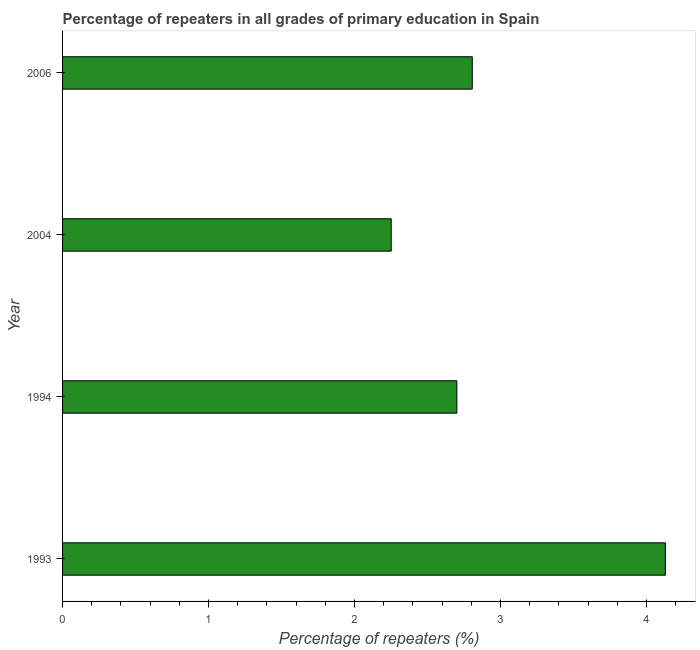Does the graph contain grids?
Keep it short and to the point. No. What is the title of the graph?
Your response must be concise. Percentage of repeaters in all grades of primary education in Spain. What is the label or title of the X-axis?
Make the answer very short. Percentage of repeaters (%). What is the percentage of repeaters in primary education in 1994?
Your answer should be compact. 2.7. Across all years, what is the maximum percentage of repeaters in primary education?
Provide a succinct answer. 4.13. Across all years, what is the minimum percentage of repeaters in primary education?
Give a very brief answer. 2.25. In which year was the percentage of repeaters in primary education maximum?
Your response must be concise. 1993. In which year was the percentage of repeaters in primary education minimum?
Provide a succinct answer. 2004. What is the sum of the percentage of repeaters in primary education?
Your answer should be very brief. 11.89. What is the difference between the percentage of repeaters in primary education in 2004 and 2006?
Offer a very short reply. -0.56. What is the average percentage of repeaters in primary education per year?
Keep it short and to the point. 2.97. What is the median percentage of repeaters in primary education?
Offer a very short reply. 2.75. In how many years, is the percentage of repeaters in primary education greater than 2.8 %?
Make the answer very short. 2. Do a majority of the years between 2006 and 2004 (inclusive) have percentage of repeaters in primary education greater than 3 %?
Your answer should be very brief. No. What is the ratio of the percentage of repeaters in primary education in 1993 to that in 2006?
Offer a very short reply. 1.47. Is the percentage of repeaters in primary education in 1993 less than that in 1994?
Your response must be concise. No. Is the difference between the percentage of repeaters in primary education in 2004 and 2006 greater than the difference between any two years?
Give a very brief answer. No. What is the difference between the highest and the second highest percentage of repeaters in primary education?
Provide a short and direct response. 1.32. Is the sum of the percentage of repeaters in primary education in 2004 and 2006 greater than the maximum percentage of repeaters in primary education across all years?
Offer a very short reply. Yes. What is the difference between the highest and the lowest percentage of repeaters in primary education?
Ensure brevity in your answer.  1.88. How many years are there in the graph?
Make the answer very short. 4. What is the difference between two consecutive major ticks on the X-axis?
Keep it short and to the point. 1. Are the values on the major ticks of X-axis written in scientific E-notation?
Provide a succinct answer. No. What is the Percentage of repeaters (%) of 1993?
Ensure brevity in your answer.  4.13. What is the Percentage of repeaters (%) of 1994?
Your answer should be very brief. 2.7. What is the Percentage of repeaters (%) of 2004?
Your answer should be very brief. 2.25. What is the Percentage of repeaters (%) of 2006?
Provide a short and direct response. 2.81. What is the difference between the Percentage of repeaters (%) in 1993 and 1994?
Offer a very short reply. 1.43. What is the difference between the Percentage of repeaters (%) in 1993 and 2004?
Make the answer very short. 1.88. What is the difference between the Percentage of repeaters (%) in 1993 and 2006?
Your answer should be compact. 1.32. What is the difference between the Percentage of repeaters (%) in 1994 and 2004?
Keep it short and to the point. 0.45. What is the difference between the Percentage of repeaters (%) in 1994 and 2006?
Your answer should be very brief. -0.11. What is the difference between the Percentage of repeaters (%) in 2004 and 2006?
Provide a short and direct response. -0.56. What is the ratio of the Percentage of repeaters (%) in 1993 to that in 1994?
Give a very brief answer. 1.53. What is the ratio of the Percentage of repeaters (%) in 1993 to that in 2004?
Ensure brevity in your answer.  1.83. What is the ratio of the Percentage of repeaters (%) in 1993 to that in 2006?
Give a very brief answer. 1.47. What is the ratio of the Percentage of repeaters (%) in 1994 to that in 2004?
Your answer should be very brief. 1.2. What is the ratio of the Percentage of repeaters (%) in 1994 to that in 2006?
Provide a succinct answer. 0.96. What is the ratio of the Percentage of repeaters (%) in 2004 to that in 2006?
Your response must be concise. 0.8. 